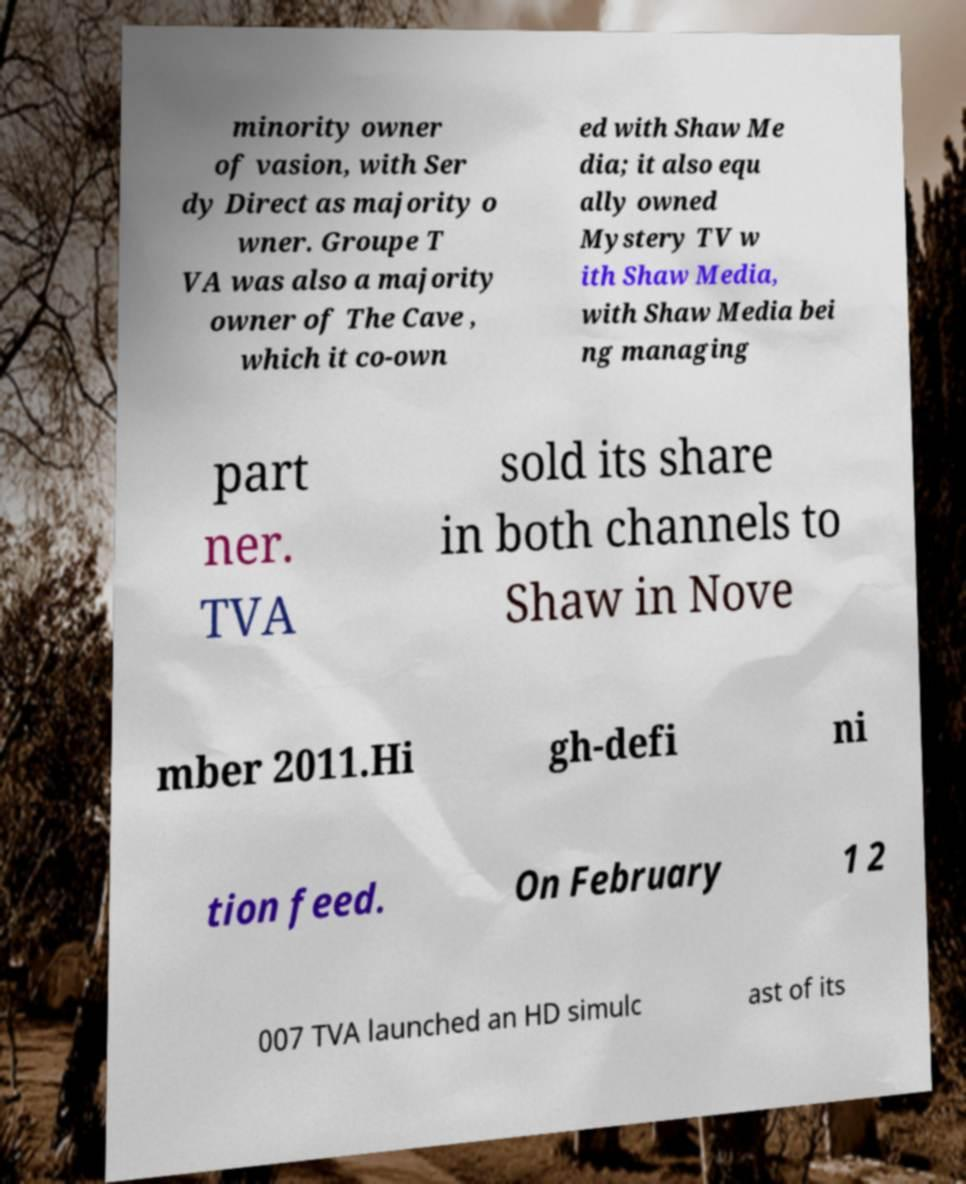Could you assist in decoding the text presented in this image and type it out clearly? minority owner of vasion, with Ser dy Direct as majority o wner. Groupe T VA was also a majority owner of The Cave , which it co-own ed with Shaw Me dia; it also equ ally owned Mystery TV w ith Shaw Media, with Shaw Media bei ng managing part ner. TVA sold its share in both channels to Shaw in Nove mber 2011.Hi gh-defi ni tion feed. On February 1 2 007 TVA launched an HD simulc ast of its 